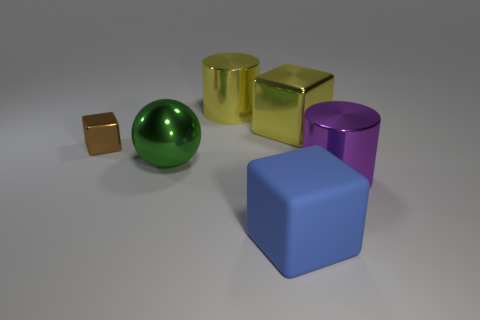Subtract all large yellow cubes. How many cubes are left? 2 Add 2 big green balls. How many objects exist? 8 Subtract all balls. How many objects are left? 5 Add 6 large shiny spheres. How many large shiny spheres are left? 7 Add 1 yellow cubes. How many yellow cubes exist? 2 Subtract 0 yellow balls. How many objects are left? 6 Subtract all yellow cylinders. Subtract all green spheres. How many cylinders are left? 1 Subtract all large blue things. Subtract all tiny shiny blocks. How many objects are left? 4 